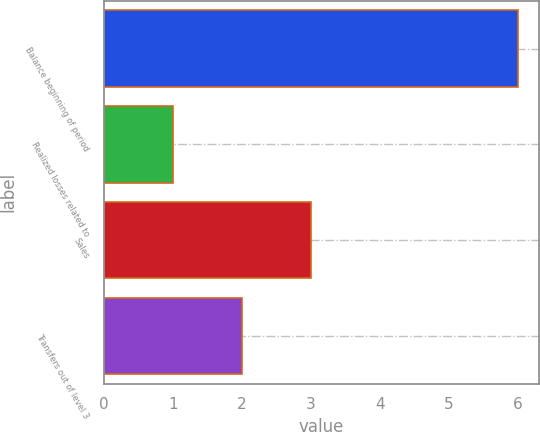Convert chart. <chart><loc_0><loc_0><loc_500><loc_500><bar_chart><fcel>Balance beginning of period<fcel>Realized losses related to<fcel>Sales<fcel>Transfers out of level 3<nl><fcel>6<fcel>1<fcel>3<fcel>2<nl></chart> 